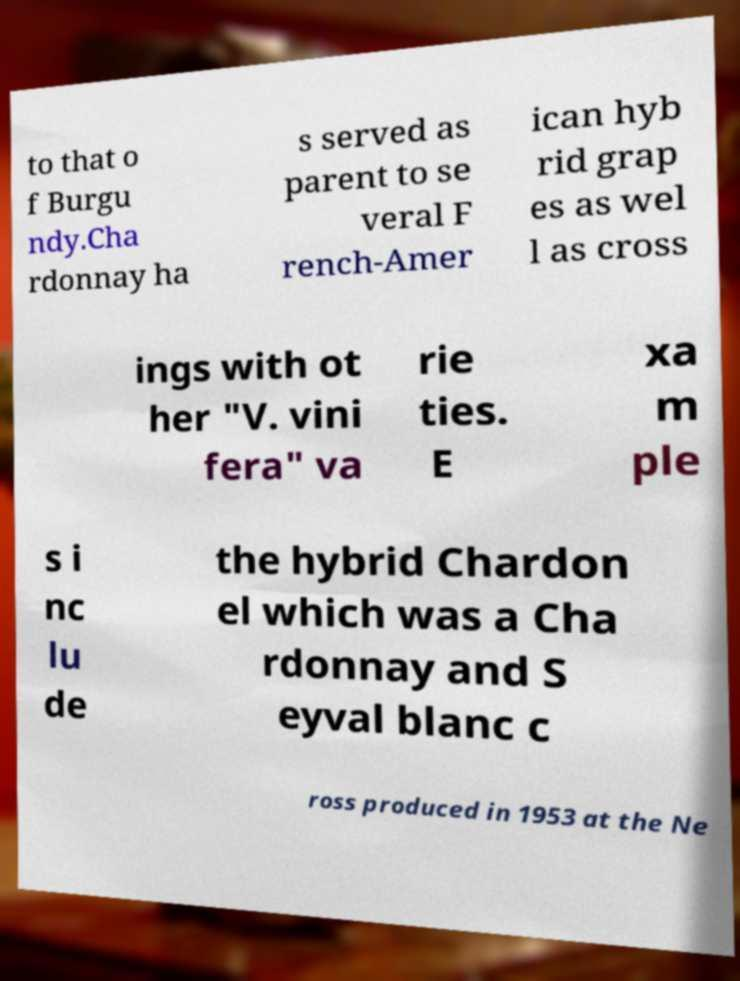There's text embedded in this image that I need extracted. Can you transcribe it verbatim? to that o f Burgu ndy.Cha rdonnay ha s served as parent to se veral F rench-Amer ican hyb rid grap es as wel l as cross ings with ot her "V. vini fera" va rie ties. E xa m ple s i nc lu de the hybrid Chardon el which was a Cha rdonnay and S eyval blanc c ross produced in 1953 at the Ne 